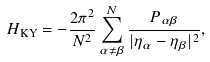Convert formula to latex. <formula><loc_0><loc_0><loc_500><loc_500>H _ { \text {KY} } = - \frac { 2 \pi ^ { 2 } } { N ^ { 2 } } \sum _ { \alpha \neq \beta } ^ { N } \frac { P _ { \alpha \beta } } { | \eta _ { \alpha } - \eta _ { \beta } | ^ { 2 } } ,</formula> 